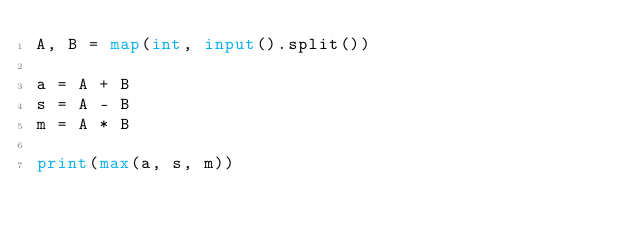<code> <loc_0><loc_0><loc_500><loc_500><_Python_>A, B = map(int, input().split())

a = A + B
s = A - B
m = A * B

print(max(a, s, m))</code> 